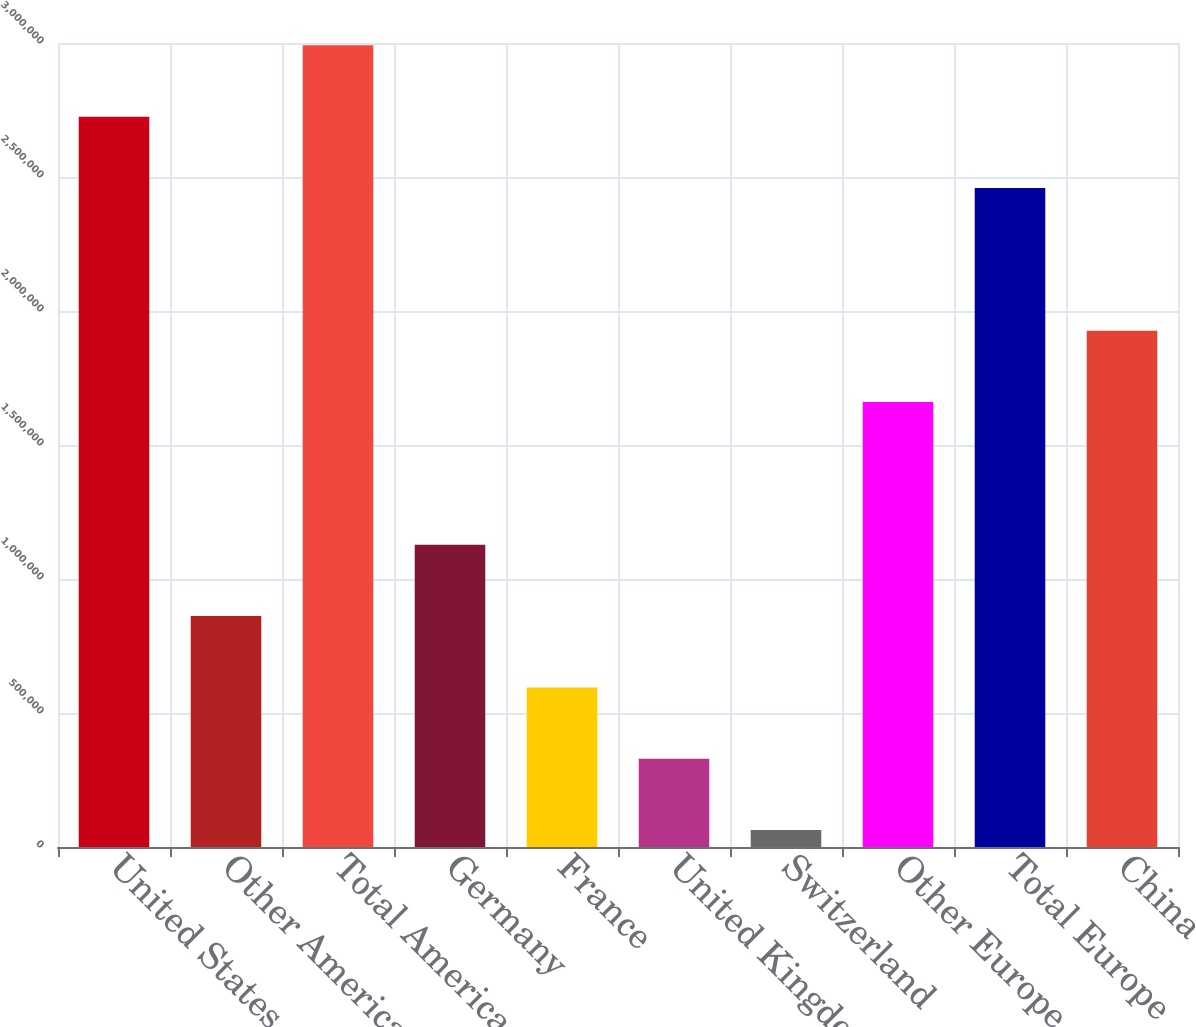<chart> <loc_0><loc_0><loc_500><loc_500><bar_chart><fcel>United States<fcel>Other Americas<fcel>Total Americas<fcel>Germany<fcel>France<fcel>United Kingdom<fcel>Switzerland<fcel>Other Europe<fcel>Total Europe<fcel>China<nl><fcel>2.72505e+06<fcel>861679<fcel>2.99125e+06<fcel>1.12788e+06<fcel>595483<fcel>329286<fcel>63090<fcel>1.66027e+06<fcel>2.45886e+06<fcel>1.92646e+06<nl></chart> 